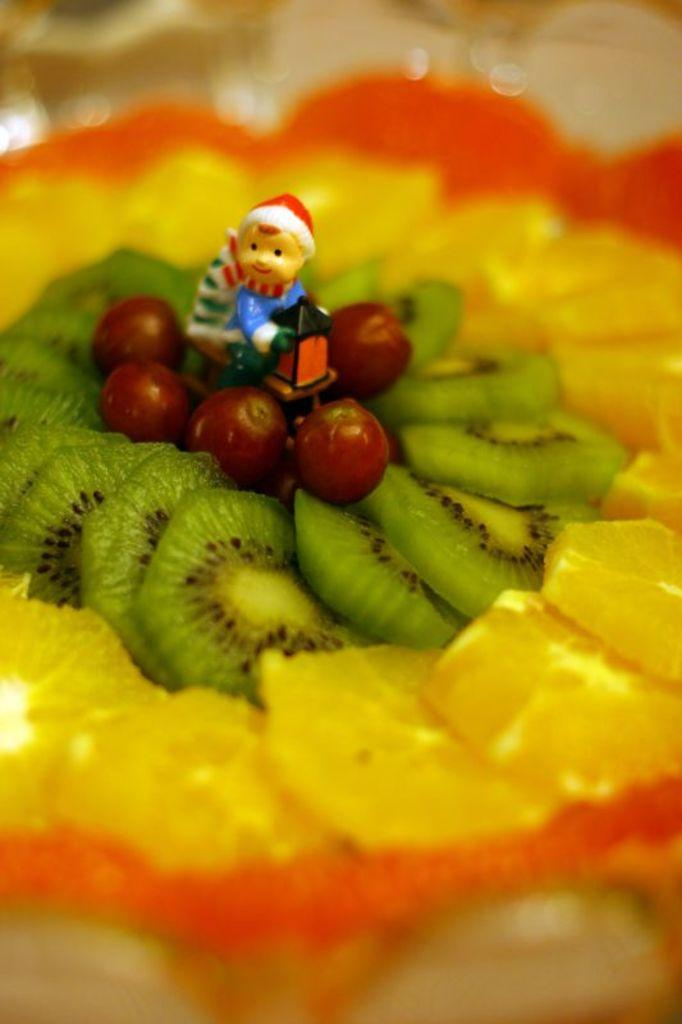What type of food is visible in the image? There are sliced fruits in the image. What colors can be seen in the fruits? The fruits have orange, yellow, green, and red colors. Is there anything else present on the fruits? Yes, there is a small toy on the fruits. What type of alley can be seen in the background of the image? There is no alley present in the image; it only features sliced fruits, their colors, and a small toy. 